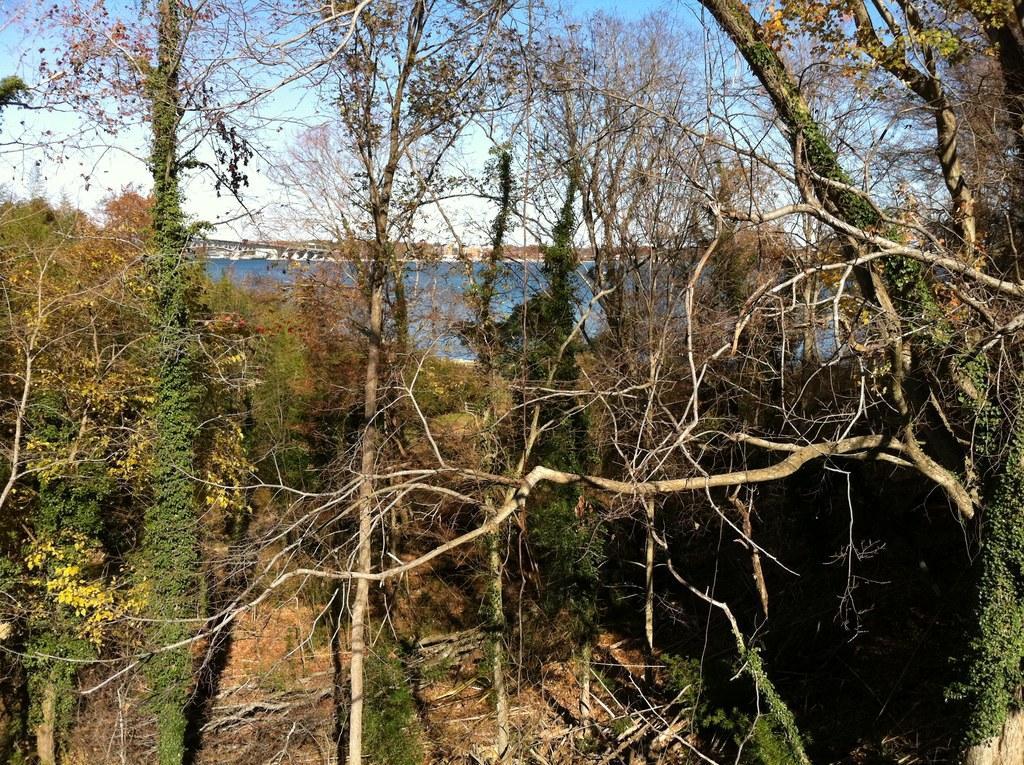Please provide a concise description of this image. In the foreground of this image, it looks like a forest with trees in the front. Water, a bridge, the sky and the clouds are in the background. 